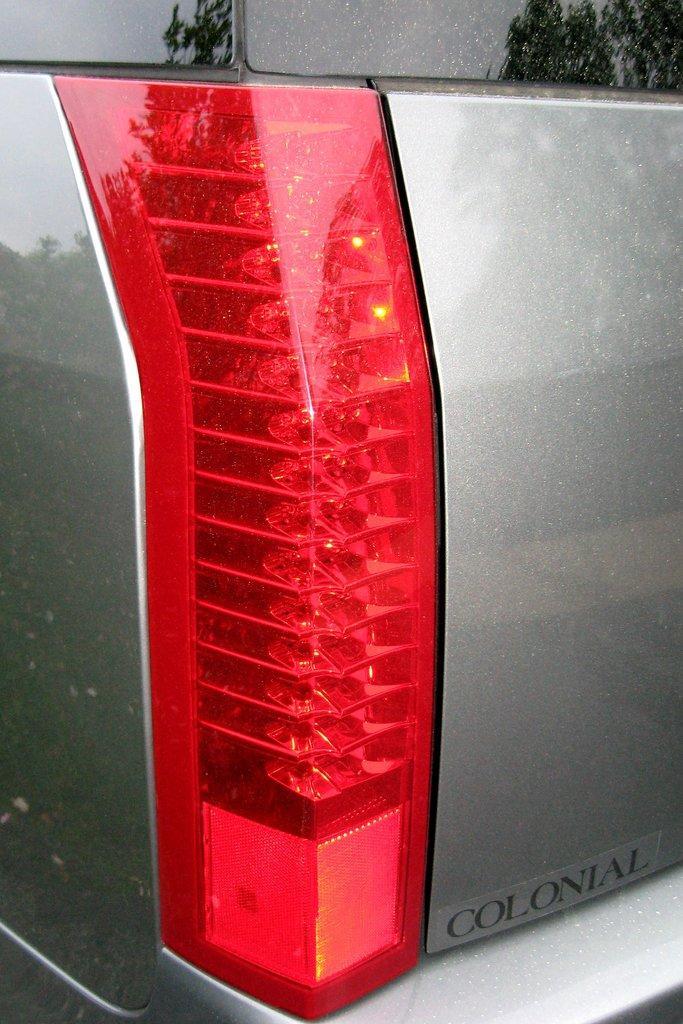Could you give a brief overview of what you see in this image? The picture consists of a tail light of a vehicle. 